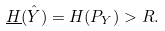Convert formula to latex. <formula><loc_0><loc_0><loc_500><loc_500>\underline { H } ( \hat { Y } ) = H ( P _ { Y } ) > R .</formula> 